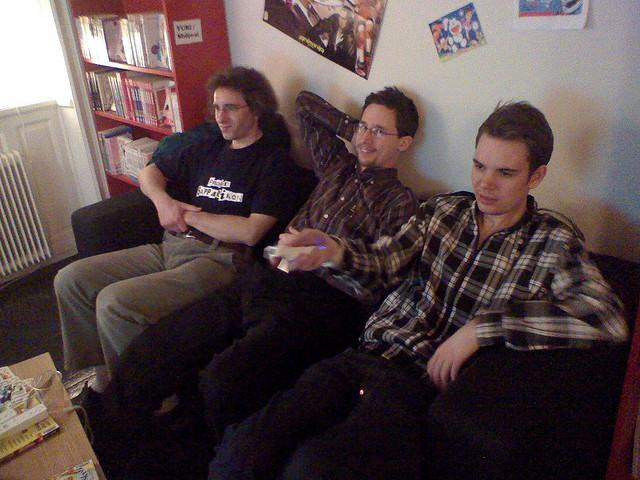What are these people engaging in? watching tv 